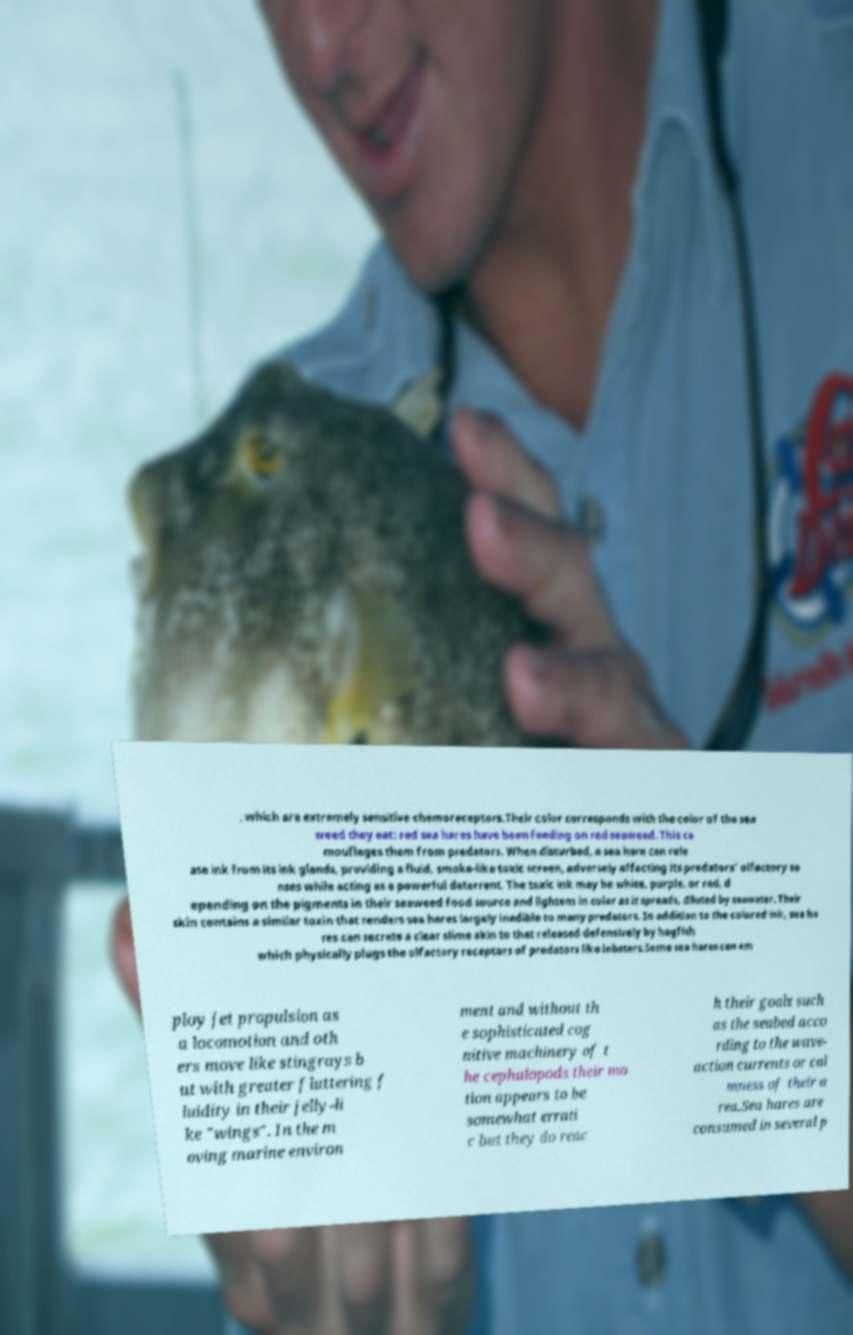Please identify and transcribe the text found in this image. , which are extremely sensitive chemoreceptors.Their color corresponds with the color of the sea weed they eat: red sea hares have been feeding on red seaweed. This ca mouflages them from predators. When disturbed, a sea hare can rele ase ink from its ink glands, providing a fluid, smoke-like toxic screen, adversely affecting its predators' olfactory se nses while acting as a powerful deterrent. The toxic ink may be white, purple, or red, d epending on the pigments in their seaweed food source and lightens in color as it spreads, diluted by seawater. Their skin contains a similar toxin that renders sea hares largely inedible to many predators. In addition to the colored ink, sea ha res can secrete a clear slime akin to that released defensively by hagfish which physically plugs the olfactory receptors of predators like lobsters.Some sea hares can em ploy jet propulsion as a locomotion and oth ers move like stingrays b ut with greater fluttering f luidity in their jelly-li ke "wings". In the m oving marine environ ment and without th e sophisticated cog nitive machinery of t he cephalopods their mo tion appears to be somewhat errati c but they do reac h their goals such as the seabed acco rding to the wave- action currents or cal mness of their a rea.Sea hares are consumed in several p 